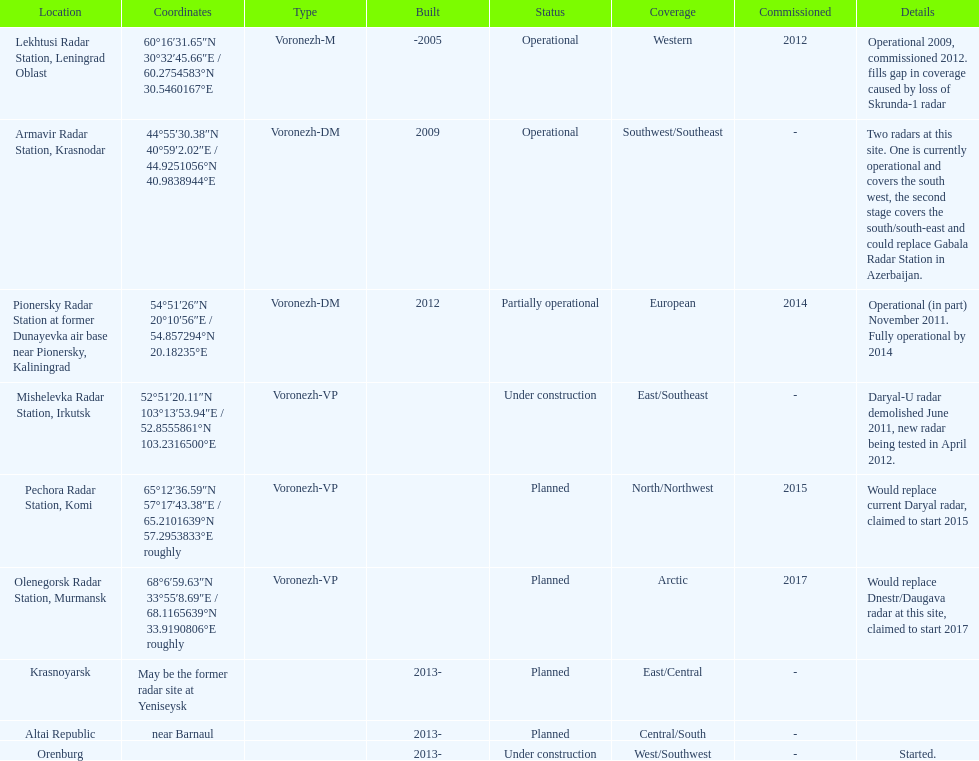What year built is at the top? -2005. 